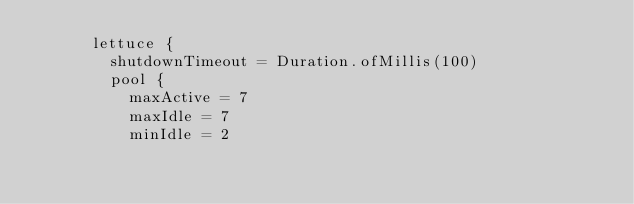Convert code to text. <code><loc_0><loc_0><loc_500><loc_500><_Kotlin_>			lettuce {
				shutdownTimeout = Duration.ofMillis(100)
				pool {
					maxActive = 7
					maxIdle = 7
					minIdle = 2</code> 